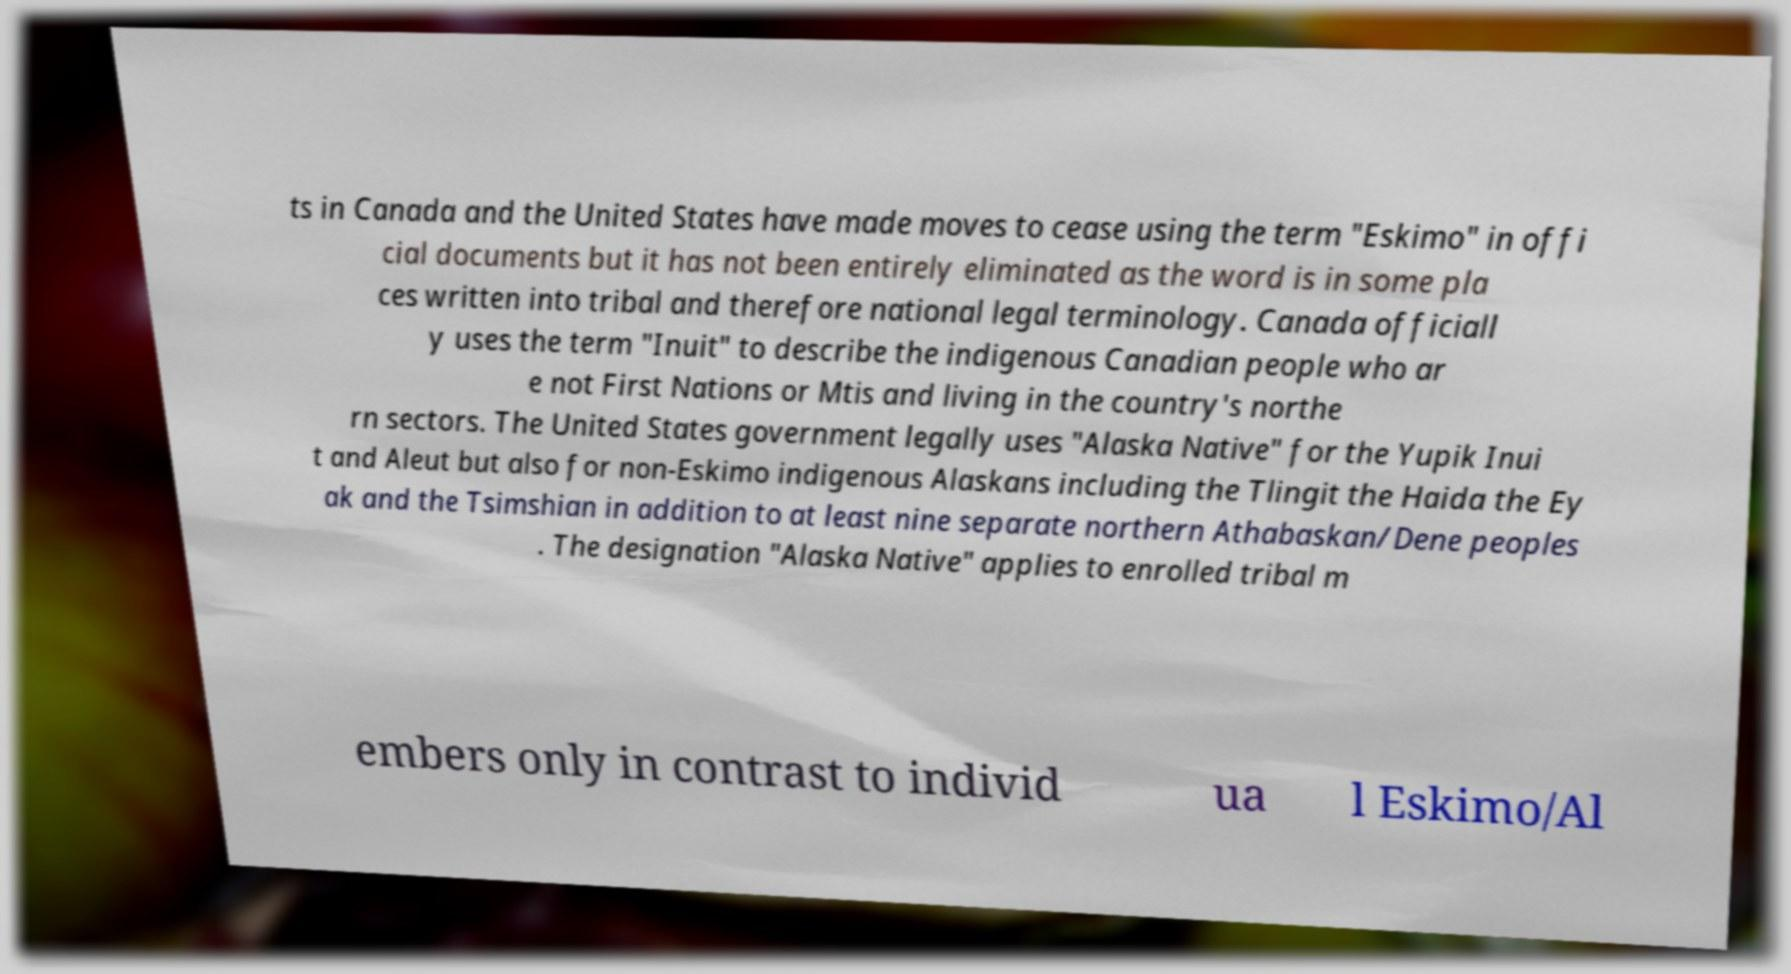Please identify and transcribe the text found in this image. ts in Canada and the United States have made moves to cease using the term "Eskimo" in offi cial documents but it has not been entirely eliminated as the word is in some pla ces written into tribal and therefore national legal terminology. Canada officiall y uses the term "Inuit" to describe the indigenous Canadian people who ar e not First Nations or Mtis and living in the country's northe rn sectors. The United States government legally uses "Alaska Native" for the Yupik Inui t and Aleut but also for non-Eskimo indigenous Alaskans including the Tlingit the Haida the Ey ak and the Tsimshian in addition to at least nine separate northern Athabaskan/Dene peoples . The designation "Alaska Native" applies to enrolled tribal m embers only in contrast to individ ua l Eskimo/Al 